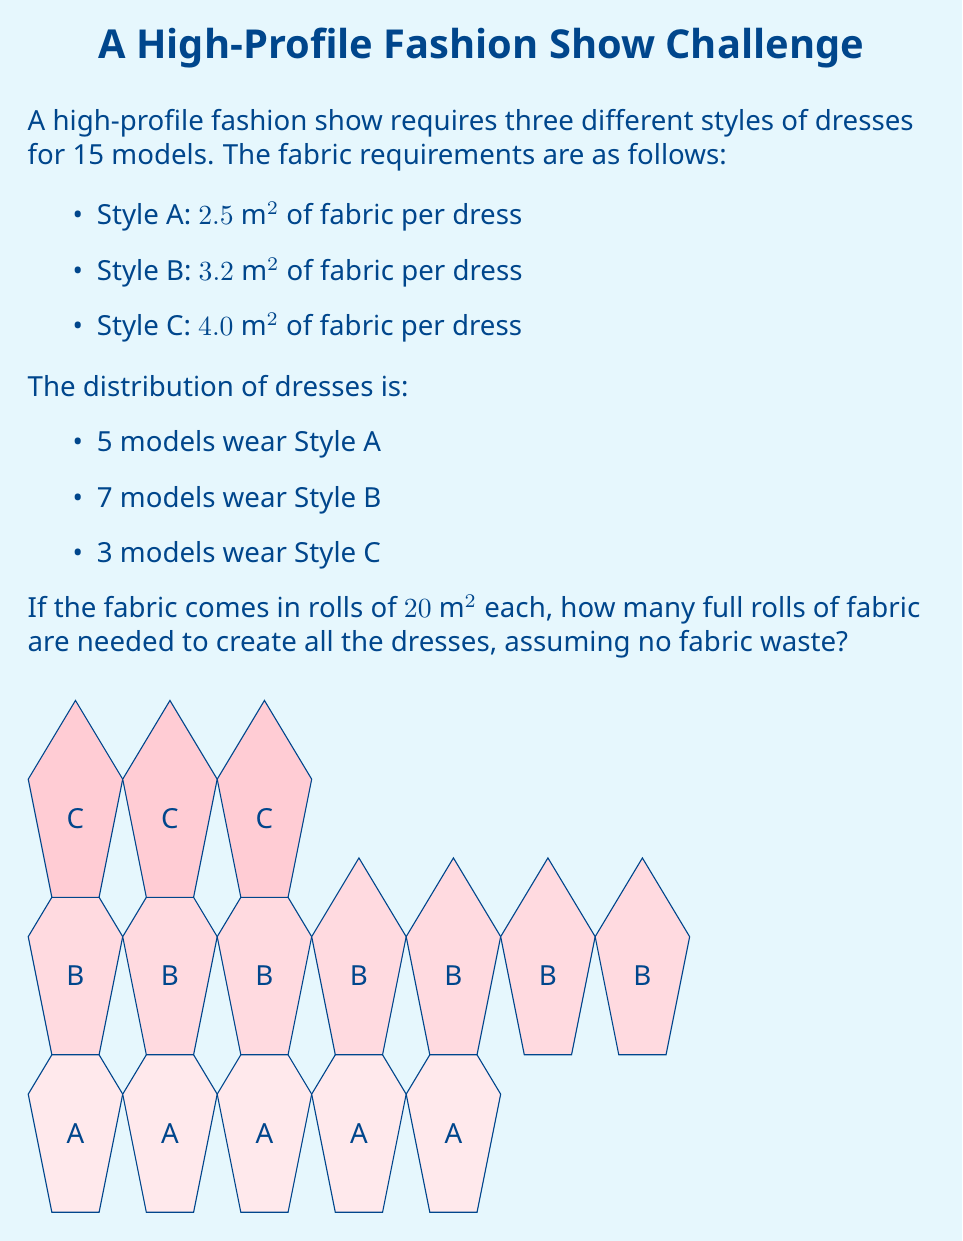Teach me how to tackle this problem. Let's approach this step-by-step:

1) First, calculate the total fabric needed for each style:

   Style A: $5 \times 2.5\text{ m}^2 = 12.5\text{ m}^2$
   Style B: $7 \times 3.2\text{ m}^2 = 22.4\text{ m}^2$
   Style C: $3 \times 4.0\text{ m}^2 = 12.0\text{ m}^2$

2) Now, sum up the total fabric required:

   $\text{Total fabric} = 12.5\text{ m}^2 + 22.4\text{ m}^2 + 12.0\text{ m}^2 = 46.9\text{ m}^2$

3) Each roll of fabric is $20\text{ m}^2$. To find the number of rolls needed, divide the total fabric required by the size of each roll:

   $\text{Number of rolls} = \frac{46.9\text{ m}^2}{20\text{ m}^2} = 2.345$

4) Since we can only use full rolls and we're assuming no fabric waste, we need to round up to the next whole number.
Answer: 3 rolls 